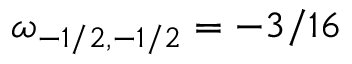<formula> <loc_0><loc_0><loc_500><loc_500>\omega _ { - 1 / 2 , - 1 / 2 } = - 3 / 1 6</formula> 